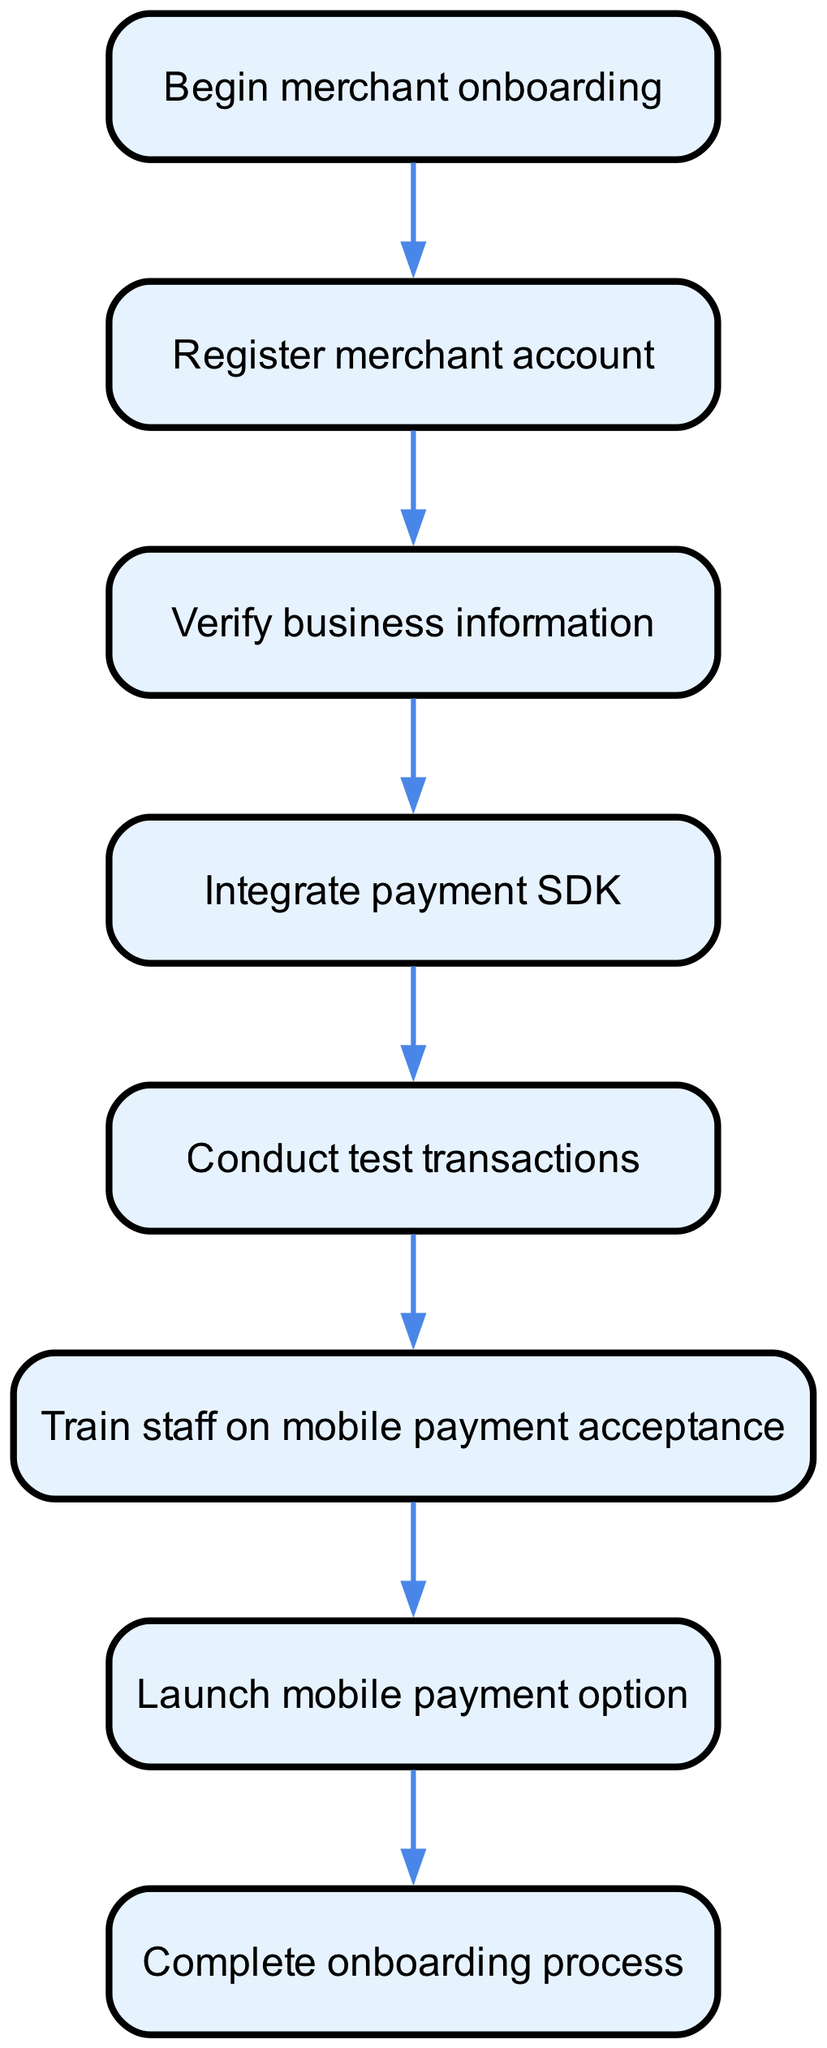What is the first step in the onboarding process? The diagram indicates that the first step is labeled as "Begin merchant onboarding." This is the starting point of the flowchart, which sets the stage for all subsequent actions.
Answer: Begin merchant onboarding What comes after registering the merchant account? According to the diagram, after "Register merchant account," the next step is "Verify business information." This establishes a direct link between the two nodes in the onboarding process flow.
Answer: Verify business information How many steps are there in the onboarding process? The diagram reveals a total of seven distinct steps, starting from "Begin merchant onboarding" and ending with "Complete onboarding process." Each labeled step represents a necessary action to be taken during the onboarding.
Answer: Seven What is the final step in the onboarding process? The last step indicated in the flowchart is labeled "Complete onboarding process." This signifies the conclusion of the onboarding journey for merchants.
Answer: Complete onboarding process What step comes before launching the mobile payment option? The diagram shows that prior to "Launch mobile payment option," the step to "Train staff on mobile payment acceptance" must be completed first. This relationship is established through the flow of arrows connecting the steps in the diagram.
Answer: Train staff on mobile payment acceptance What are the intermediary steps between verifying and launching the mobile payment option? The intermediary steps, as per the diagram, include "Integrate payment SDK" followed by "Conduct test transactions" and then "Train staff on mobile payment acceptance." This sequence reveals the required actions that must occur between verification and launch.
Answer: Integrate payment SDK, Conduct test transactions, Train staff on mobile payment acceptance How does the onboarding process start? The diagram commences with "Begin merchant onboarding," which indicates that this is the initial action taken before proceeding to the subsequent steps outlined in the flowchart.
Answer: Begin merchant onboarding What is the purpose of the "Conduct test transactions" step? In the onboarding process, "Conduct test transactions" serves to ensure the payment system functions correctly before the merchant starts accepting live transactions, as indicated in the flow.
Answer: Verify payment system functionality 